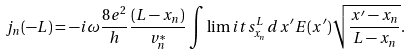<formula> <loc_0><loc_0><loc_500><loc_500>j _ { n } ( - L ) = - i \omega \frac { 8 e ^ { 2 } } { h } \frac { ( L - x _ { n } ) } { v _ { n } ^ { * } } \int \lim i t s _ { x _ { n } } ^ { L } d x ^ { \prime } E ( x ^ { \prime } ) \sqrt { \frac { x ^ { \prime } - x _ { n } } { L - x _ { n } } } .</formula> 